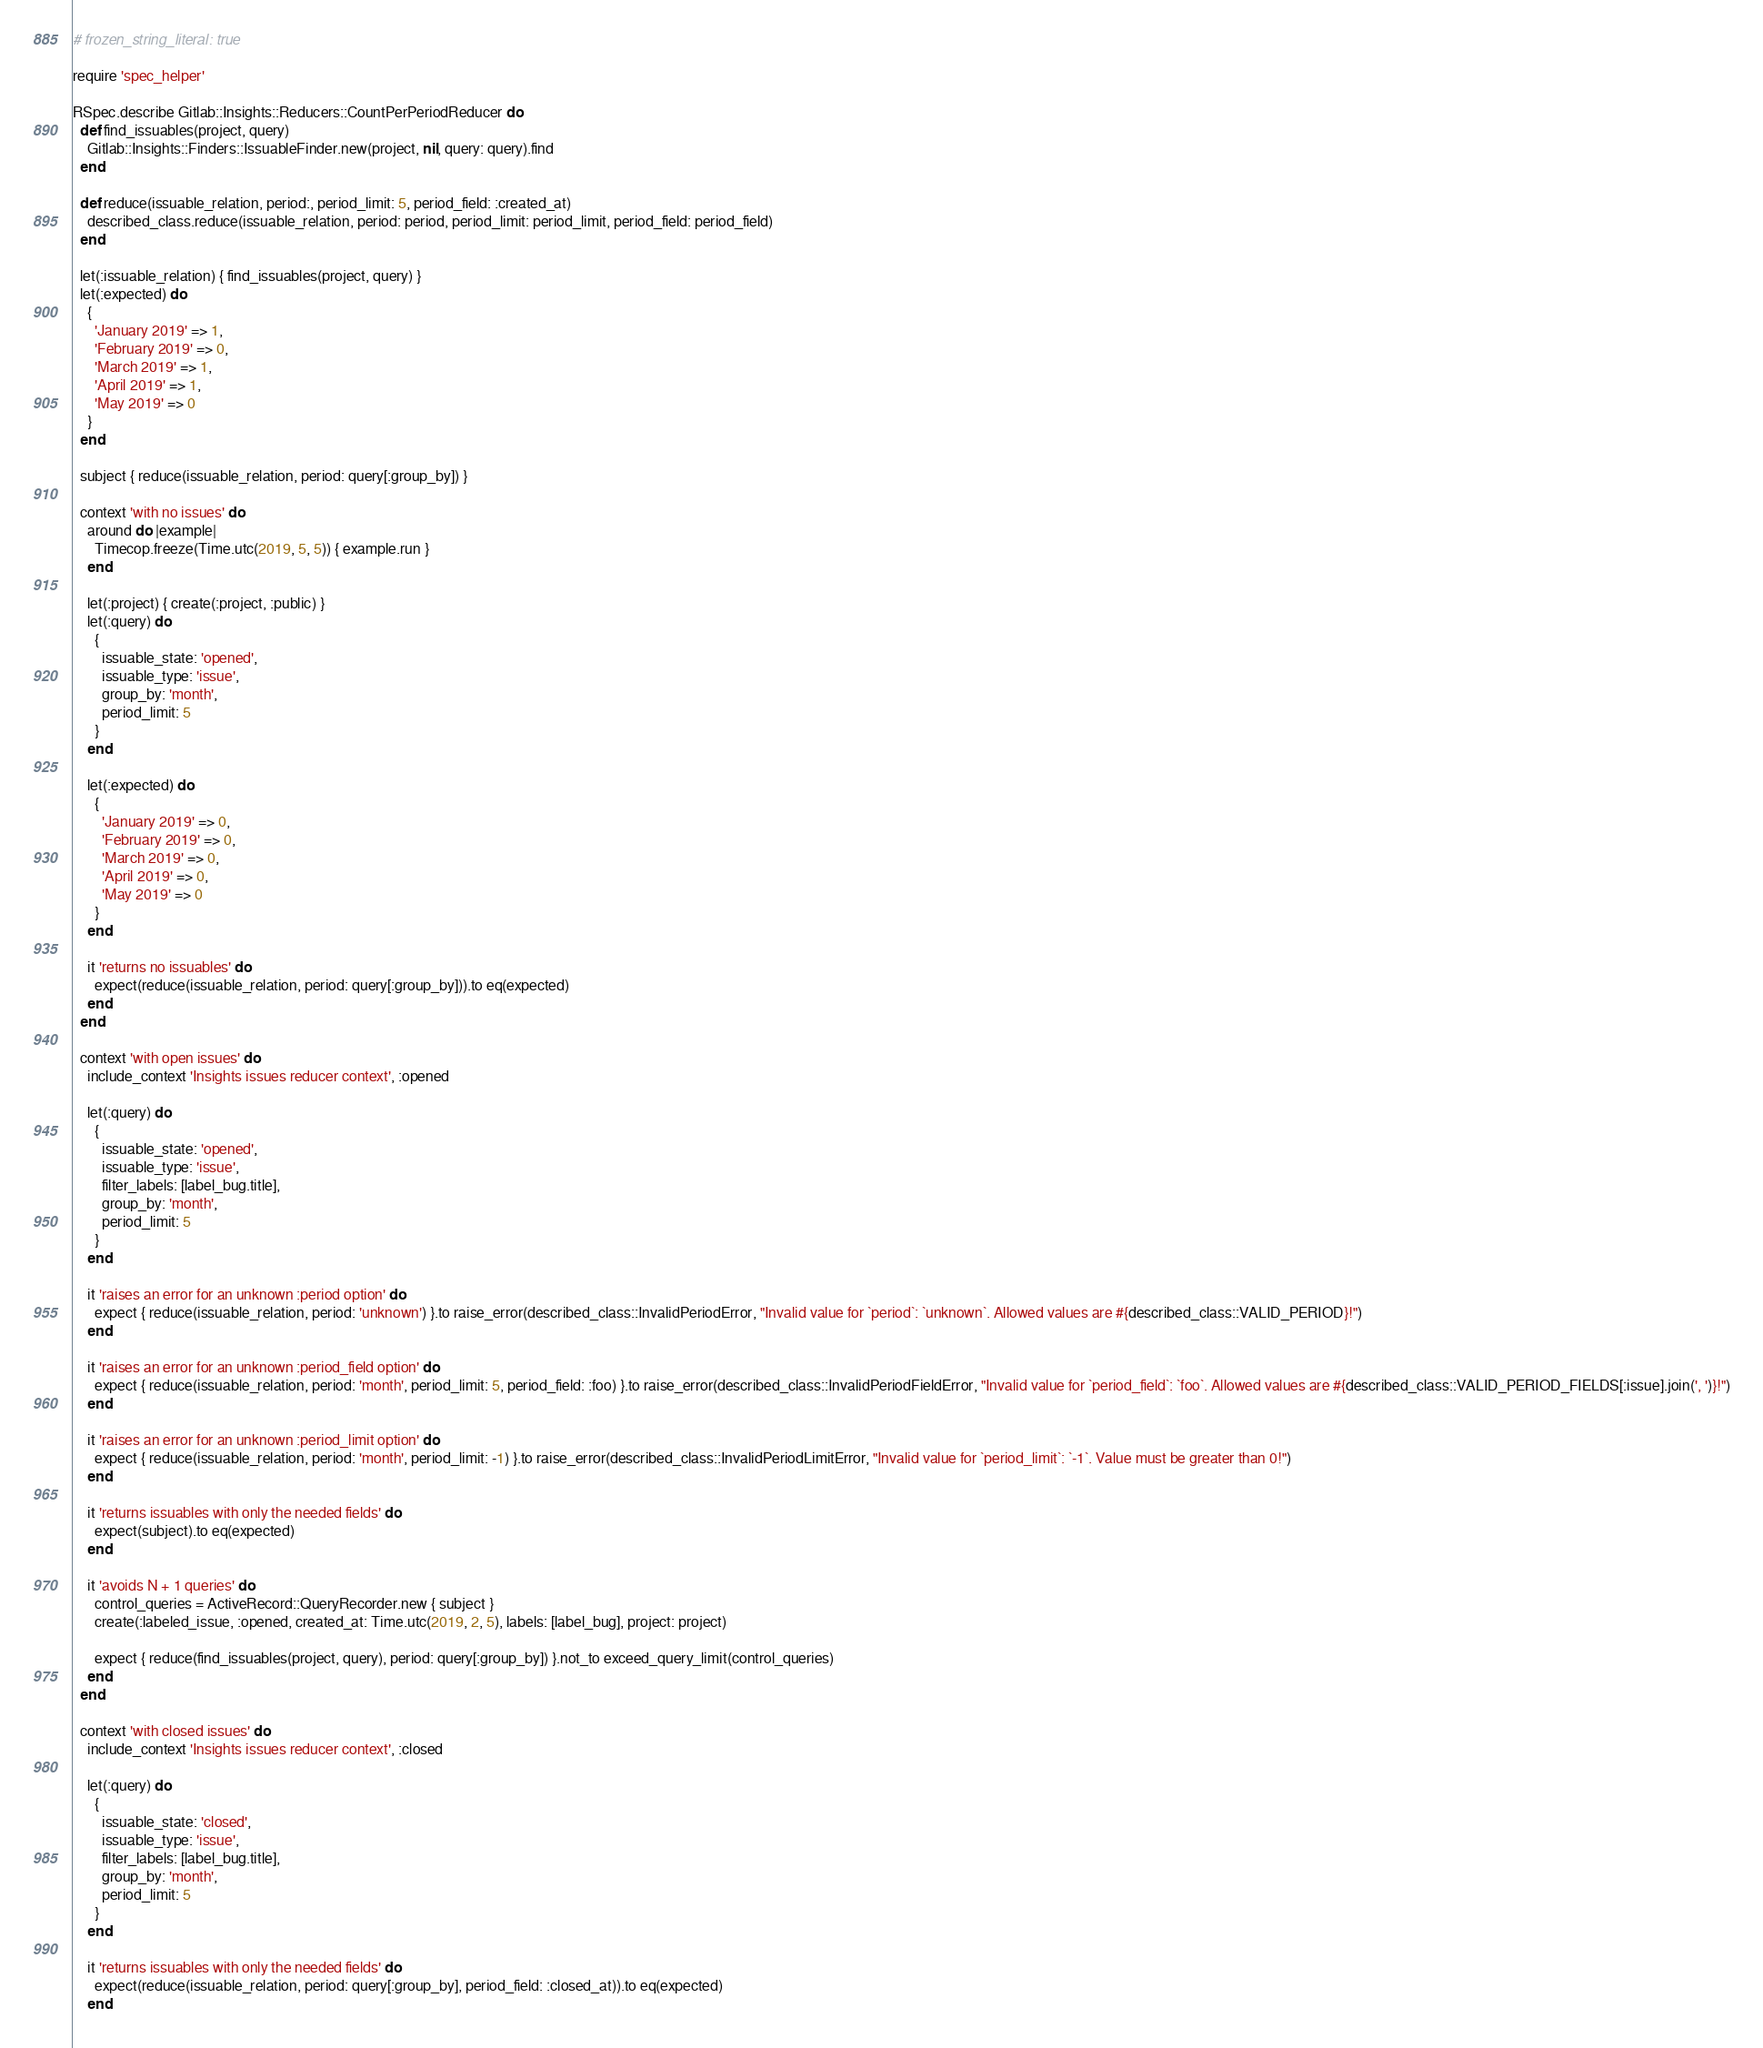<code> <loc_0><loc_0><loc_500><loc_500><_Ruby_># frozen_string_literal: true

require 'spec_helper'

RSpec.describe Gitlab::Insights::Reducers::CountPerPeriodReducer do
  def find_issuables(project, query)
    Gitlab::Insights::Finders::IssuableFinder.new(project, nil, query: query).find
  end

  def reduce(issuable_relation, period:, period_limit: 5, period_field: :created_at)
    described_class.reduce(issuable_relation, period: period, period_limit: period_limit, period_field: period_field)
  end

  let(:issuable_relation) { find_issuables(project, query) }
  let(:expected) do
    {
      'January 2019' => 1,
      'February 2019' => 0,
      'March 2019' => 1,
      'April 2019' => 1,
      'May 2019' => 0
    }
  end

  subject { reduce(issuable_relation, period: query[:group_by]) }

  context 'with no issues' do
    around do |example|
      Timecop.freeze(Time.utc(2019, 5, 5)) { example.run }
    end

    let(:project) { create(:project, :public) }
    let(:query) do
      {
        issuable_state: 'opened',
        issuable_type: 'issue',
        group_by: 'month',
        period_limit: 5
      }
    end

    let(:expected) do
      {
        'January 2019' => 0,
        'February 2019' => 0,
        'March 2019' => 0,
        'April 2019' => 0,
        'May 2019' => 0
      }
    end

    it 'returns no issuables' do
      expect(reduce(issuable_relation, period: query[:group_by])).to eq(expected)
    end
  end

  context 'with open issues' do
    include_context 'Insights issues reducer context', :opened

    let(:query) do
      {
        issuable_state: 'opened',
        issuable_type: 'issue',
        filter_labels: [label_bug.title],
        group_by: 'month',
        period_limit: 5
      }
    end

    it 'raises an error for an unknown :period option' do
      expect { reduce(issuable_relation, period: 'unknown') }.to raise_error(described_class::InvalidPeriodError, "Invalid value for `period`: `unknown`. Allowed values are #{described_class::VALID_PERIOD}!")
    end

    it 'raises an error for an unknown :period_field option' do
      expect { reduce(issuable_relation, period: 'month', period_limit: 5, period_field: :foo) }.to raise_error(described_class::InvalidPeriodFieldError, "Invalid value for `period_field`: `foo`. Allowed values are #{described_class::VALID_PERIOD_FIELDS[:issue].join(', ')}!")
    end

    it 'raises an error for an unknown :period_limit option' do
      expect { reduce(issuable_relation, period: 'month', period_limit: -1) }.to raise_error(described_class::InvalidPeriodLimitError, "Invalid value for `period_limit`: `-1`. Value must be greater than 0!")
    end

    it 'returns issuables with only the needed fields' do
      expect(subject).to eq(expected)
    end

    it 'avoids N + 1 queries' do
      control_queries = ActiveRecord::QueryRecorder.new { subject }
      create(:labeled_issue, :opened, created_at: Time.utc(2019, 2, 5), labels: [label_bug], project: project)

      expect { reduce(find_issuables(project, query), period: query[:group_by]) }.not_to exceed_query_limit(control_queries)
    end
  end

  context 'with closed issues' do
    include_context 'Insights issues reducer context', :closed

    let(:query) do
      {
        issuable_state: 'closed',
        issuable_type: 'issue',
        filter_labels: [label_bug.title],
        group_by: 'month',
        period_limit: 5
      }
    end

    it 'returns issuables with only the needed fields' do
      expect(reduce(issuable_relation, period: query[:group_by], period_field: :closed_at)).to eq(expected)
    end
</code> 